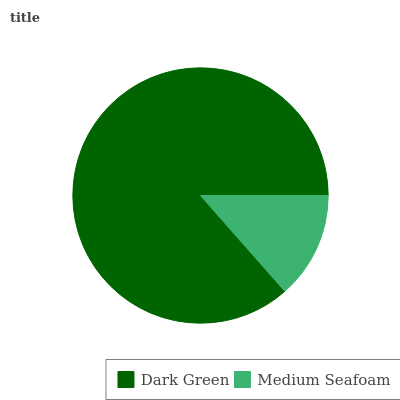Is Medium Seafoam the minimum?
Answer yes or no. Yes. Is Dark Green the maximum?
Answer yes or no. Yes. Is Medium Seafoam the maximum?
Answer yes or no. No. Is Dark Green greater than Medium Seafoam?
Answer yes or no. Yes. Is Medium Seafoam less than Dark Green?
Answer yes or no. Yes. Is Medium Seafoam greater than Dark Green?
Answer yes or no. No. Is Dark Green less than Medium Seafoam?
Answer yes or no. No. Is Dark Green the high median?
Answer yes or no. Yes. Is Medium Seafoam the low median?
Answer yes or no. Yes. Is Medium Seafoam the high median?
Answer yes or no. No. Is Dark Green the low median?
Answer yes or no. No. 